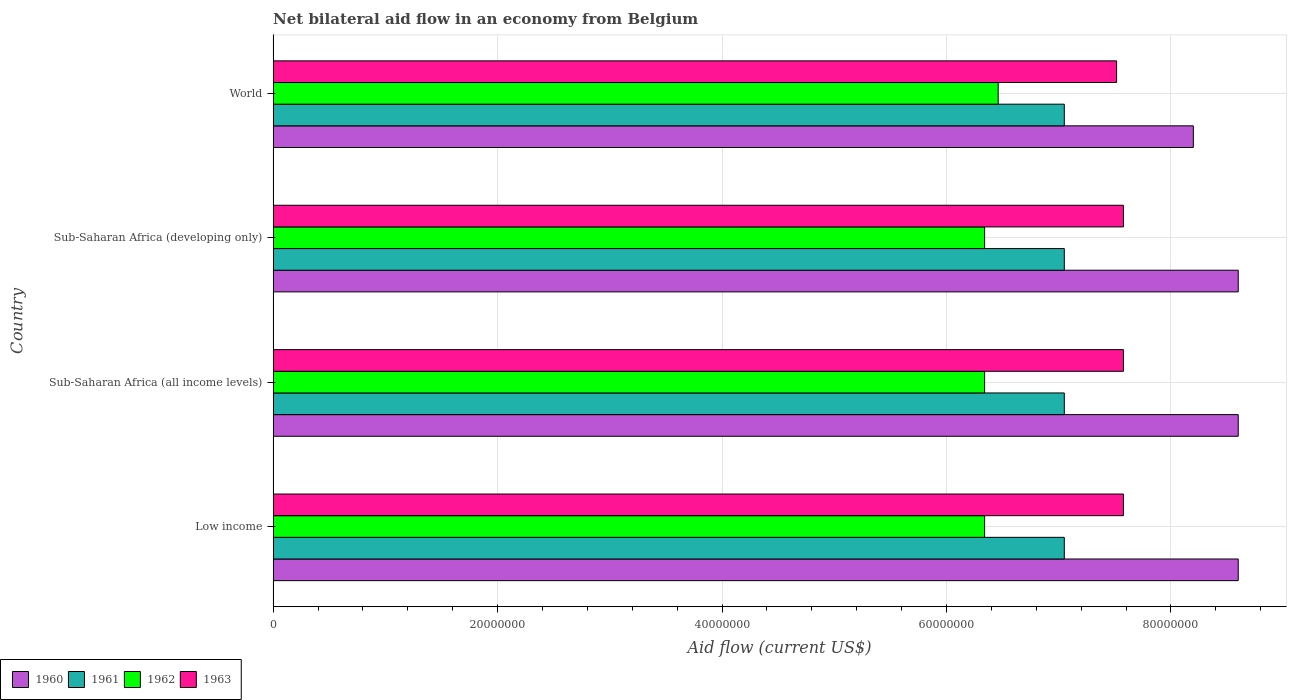How many different coloured bars are there?
Offer a terse response. 4. Are the number of bars on each tick of the Y-axis equal?
Keep it short and to the point. Yes. How many bars are there on the 4th tick from the bottom?
Offer a terse response. 4. What is the label of the 2nd group of bars from the top?
Keep it short and to the point. Sub-Saharan Africa (developing only). In how many cases, is the number of bars for a given country not equal to the number of legend labels?
Provide a succinct answer. 0. What is the net bilateral aid flow in 1960 in Low income?
Ensure brevity in your answer.  8.60e+07. Across all countries, what is the maximum net bilateral aid flow in 1962?
Your response must be concise. 6.46e+07. Across all countries, what is the minimum net bilateral aid flow in 1960?
Offer a very short reply. 8.20e+07. In which country was the net bilateral aid flow in 1961 maximum?
Provide a succinct answer. Low income. What is the total net bilateral aid flow in 1960 in the graph?
Provide a short and direct response. 3.40e+08. What is the difference between the net bilateral aid flow in 1962 in Sub-Saharan Africa (all income levels) and that in World?
Your response must be concise. -1.21e+06. What is the difference between the net bilateral aid flow in 1961 in Sub-Saharan Africa (all income levels) and the net bilateral aid flow in 1960 in World?
Offer a terse response. -1.15e+07. What is the average net bilateral aid flow in 1960 per country?
Your answer should be compact. 8.50e+07. What is the difference between the net bilateral aid flow in 1962 and net bilateral aid flow in 1960 in World?
Give a very brief answer. -1.74e+07. What is the ratio of the net bilateral aid flow in 1960 in Sub-Saharan Africa (all income levels) to that in Sub-Saharan Africa (developing only)?
Provide a succinct answer. 1. Is the sum of the net bilateral aid flow in 1961 in Low income and Sub-Saharan Africa (developing only) greater than the maximum net bilateral aid flow in 1963 across all countries?
Give a very brief answer. Yes. Is it the case that in every country, the sum of the net bilateral aid flow in 1963 and net bilateral aid flow in 1962 is greater than the sum of net bilateral aid flow in 1961 and net bilateral aid flow in 1960?
Offer a very short reply. No. What does the 2nd bar from the bottom in Low income represents?
Your answer should be compact. 1961. Are all the bars in the graph horizontal?
Make the answer very short. Yes. How many countries are there in the graph?
Ensure brevity in your answer.  4. Does the graph contain grids?
Offer a terse response. Yes. Where does the legend appear in the graph?
Your answer should be very brief. Bottom left. How many legend labels are there?
Ensure brevity in your answer.  4. How are the legend labels stacked?
Your answer should be very brief. Horizontal. What is the title of the graph?
Give a very brief answer. Net bilateral aid flow in an economy from Belgium. Does "2011" appear as one of the legend labels in the graph?
Give a very brief answer. No. What is the Aid flow (current US$) in 1960 in Low income?
Offer a terse response. 8.60e+07. What is the Aid flow (current US$) of 1961 in Low income?
Give a very brief answer. 7.05e+07. What is the Aid flow (current US$) in 1962 in Low income?
Your answer should be very brief. 6.34e+07. What is the Aid flow (current US$) of 1963 in Low income?
Make the answer very short. 7.58e+07. What is the Aid flow (current US$) in 1960 in Sub-Saharan Africa (all income levels)?
Your response must be concise. 8.60e+07. What is the Aid flow (current US$) in 1961 in Sub-Saharan Africa (all income levels)?
Offer a terse response. 7.05e+07. What is the Aid flow (current US$) in 1962 in Sub-Saharan Africa (all income levels)?
Provide a succinct answer. 6.34e+07. What is the Aid flow (current US$) of 1963 in Sub-Saharan Africa (all income levels)?
Your answer should be very brief. 7.58e+07. What is the Aid flow (current US$) of 1960 in Sub-Saharan Africa (developing only)?
Provide a succinct answer. 8.60e+07. What is the Aid flow (current US$) of 1961 in Sub-Saharan Africa (developing only)?
Ensure brevity in your answer.  7.05e+07. What is the Aid flow (current US$) of 1962 in Sub-Saharan Africa (developing only)?
Your answer should be very brief. 6.34e+07. What is the Aid flow (current US$) of 1963 in Sub-Saharan Africa (developing only)?
Your response must be concise. 7.58e+07. What is the Aid flow (current US$) of 1960 in World?
Your answer should be compact. 8.20e+07. What is the Aid flow (current US$) in 1961 in World?
Offer a very short reply. 7.05e+07. What is the Aid flow (current US$) of 1962 in World?
Your answer should be very brief. 6.46e+07. What is the Aid flow (current US$) of 1963 in World?
Your response must be concise. 7.52e+07. Across all countries, what is the maximum Aid flow (current US$) of 1960?
Ensure brevity in your answer.  8.60e+07. Across all countries, what is the maximum Aid flow (current US$) of 1961?
Provide a succinct answer. 7.05e+07. Across all countries, what is the maximum Aid flow (current US$) in 1962?
Provide a succinct answer. 6.46e+07. Across all countries, what is the maximum Aid flow (current US$) of 1963?
Your answer should be very brief. 7.58e+07. Across all countries, what is the minimum Aid flow (current US$) of 1960?
Offer a very short reply. 8.20e+07. Across all countries, what is the minimum Aid flow (current US$) in 1961?
Keep it short and to the point. 7.05e+07. Across all countries, what is the minimum Aid flow (current US$) in 1962?
Your answer should be compact. 6.34e+07. Across all countries, what is the minimum Aid flow (current US$) of 1963?
Offer a very short reply. 7.52e+07. What is the total Aid flow (current US$) in 1960 in the graph?
Give a very brief answer. 3.40e+08. What is the total Aid flow (current US$) of 1961 in the graph?
Provide a short and direct response. 2.82e+08. What is the total Aid flow (current US$) in 1962 in the graph?
Provide a short and direct response. 2.55e+08. What is the total Aid flow (current US$) of 1963 in the graph?
Keep it short and to the point. 3.02e+08. What is the difference between the Aid flow (current US$) of 1962 in Low income and that in Sub-Saharan Africa (all income levels)?
Ensure brevity in your answer.  0. What is the difference between the Aid flow (current US$) in 1963 in Low income and that in Sub-Saharan Africa (all income levels)?
Your answer should be very brief. 0. What is the difference between the Aid flow (current US$) of 1960 in Low income and that in Sub-Saharan Africa (developing only)?
Give a very brief answer. 0. What is the difference between the Aid flow (current US$) of 1962 in Low income and that in Sub-Saharan Africa (developing only)?
Your response must be concise. 0. What is the difference between the Aid flow (current US$) of 1961 in Low income and that in World?
Keep it short and to the point. 0. What is the difference between the Aid flow (current US$) in 1962 in Low income and that in World?
Your response must be concise. -1.21e+06. What is the difference between the Aid flow (current US$) of 1962 in Sub-Saharan Africa (all income levels) and that in Sub-Saharan Africa (developing only)?
Provide a succinct answer. 0. What is the difference between the Aid flow (current US$) in 1963 in Sub-Saharan Africa (all income levels) and that in Sub-Saharan Africa (developing only)?
Your answer should be very brief. 0. What is the difference between the Aid flow (current US$) in 1962 in Sub-Saharan Africa (all income levels) and that in World?
Offer a very short reply. -1.21e+06. What is the difference between the Aid flow (current US$) of 1963 in Sub-Saharan Africa (all income levels) and that in World?
Your answer should be very brief. 6.10e+05. What is the difference between the Aid flow (current US$) of 1960 in Sub-Saharan Africa (developing only) and that in World?
Ensure brevity in your answer.  4.00e+06. What is the difference between the Aid flow (current US$) in 1961 in Sub-Saharan Africa (developing only) and that in World?
Your answer should be very brief. 0. What is the difference between the Aid flow (current US$) in 1962 in Sub-Saharan Africa (developing only) and that in World?
Give a very brief answer. -1.21e+06. What is the difference between the Aid flow (current US$) in 1960 in Low income and the Aid flow (current US$) in 1961 in Sub-Saharan Africa (all income levels)?
Provide a short and direct response. 1.55e+07. What is the difference between the Aid flow (current US$) in 1960 in Low income and the Aid flow (current US$) in 1962 in Sub-Saharan Africa (all income levels)?
Your response must be concise. 2.26e+07. What is the difference between the Aid flow (current US$) in 1960 in Low income and the Aid flow (current US$) in 1963 in Sub-Saharan Africa (all income levels)?
Offer a terse response. 1.02e+07. What is the difference between the Aid flow (current US$) of 1961 in Low income and the Aid flow (current US$) of 1962 in Sub-Saharan Africa (all income levels)?
Offer a very short reply. 7.10e+06. What is the difference between the Aid flow (current US$) in 1961 in Low income and the Aid flow (current US$) in 1963 in Sub-Saharan Africa (all income levels)?
Your answer should be very brief. -5.27e+06. What is the difference between the Aid flow (current US$) of 1962 in Low income and the Aid flow (current US$) of 1963 in Sub-Saharan Africa (all income levels)?
Your response must be concise. -1.24e+07. What is the difference between the Aid flow (current US$) of 1960 in Low income and the Aid flow (current US$) of 1961 in Sub-Saharan Africa (developing only)?
Offer a terse response. 1.55e+07. What is the difference between the Aid flow (current US$) in 1960 in Low income and the Aid flow (current US$) in 1962 in Sub-Saharan Africa (developing only)?
Keep it short and to the point. 2.26e+07. What is the difference between the Aid flow (current US$) in 1960 in Low income and the Aid flow (current US$) in 1963 in Sub-Saharan Africa (developing only)?
Your answer should be very brief. 1.02e+07. What is the difference between the Aid flow (current US$) in 1961 in Low income and the Aid flow (current US$) in 1962 in Sub-Saharan Africa (developing only)?
Give a very brief answer. 7.10e+06. What is the difference between the Aid flow (current US$) of 1961 in Low income and the Aid flow (current US$) of 1963 in Sub-Saharan Africa (developing only)?
Your answer should be very brief. -5.27e+06. What is the difference between the Aid flow (current US$) in 1962 in Low income and the Aid flow (current US$) in 1963 in Sub-Saharan Africa (developing only)?
Make the answer very short. -1.24e+07. What is the difference between the Aid flow (current US$) of 1960 in Low income and the Aid flow (current US$) of 1961 in World?
Your response must be concise. 1.55e+07. What is the difference between the Aid flow (current US$) in 1960 in Low income and the Aid flow (current US$) in 1962 in World?
Offer a very short reply. 2.14e+07. What is the difference between the Aid flow (current US$) of 1960 in Low income and the Aid flow (current US$) of 1963 in World?
Offer a very short reply. 1.08e+07. What is the difference between the Aid flow (current US$) of 1961 in Low income and the Aid flow (current US$) of 1962 in World?
Your answer should be very brief. 5.89e+06. What is the difference between the Aid flow (current US$) in 1961 in Low income and the Aid flow (current US$) in 1963 in World?
Your response must be concise. -4.66e+06. What is the difference between the Aid flow (current US$) of 1962 in Low income and the Aid flow (current US$) of 1963 in World?
Provide a succinct answer. -1.18e+07. What is the difference between the Aid flow (current US$) of 1960 in Sub-Saharan Africa (all income levels) and the Aid flow (current US$) of 1961 in Sub-Saharan Africa (developing only)?
Provide a succinct answer. 1.55e+07. What is the difference between the Aid flow (current US$) of 1960 in Sub-Saharan Africa (all income levels) and the Aid flow (current US$) of 1962 in Sub-Saharan Africa (developing only)?
Your answer should be compact. 2.26e+07. What is the difference between the Aid flow (current US$) of 1960 in Sub-Saharan Africa (all income levels) and the Aid flow (current US$) of 1963 in Sub-Saharan Africa (developing only)?
Offer a very short reply. 1.02e+07. What is the difference between the Aid flow (current US$) in 1961 in Sub-Saharan Africa (all income levels) and the Aid flow (current US$) in 1962 in Sub-Saharan Africa (developing only)?
Keep it short and to the point. 7.10e+06. What is the difference between the Aid flow (current US$) in 1961 in Sub-Saharan Africa (all income levels) and the Aid flow (current US$) in 1963 in Sub-Saharan Africa (developing only)?
Provide a succinct answer. -5.27e+06. What is the difference between the Aid flow (current US$) of 1962 in Sub-Saharan Africa (all income levels) and the Aid flow (current US$) of 1963 in Sub-Saharan Africa (developing only)?
Give a very brief answer. -1.24e+07. What is the difference between the Aid flow (current US$) in 1960 in Sub-Saharan Africa (all income levels) and the Aid flow (current US$) in 1961 in World?
Your answer should be compact. 1.55e+07. What is the difference between the Aid flow (current US$) in 1960 in Sub-Saharan Africa (all income levels) and the Aid flow (current US$) in 1962 in World?
Make the answer very short. 2.14e+07. What is the difference between the Aid flow (current US$) in 1960 in Sub-Saharan Africa (all income levels) and the Aid flow (current US$) in 1963 in World?
Your answer should be very brief. 1.08e+07. What is the difference between the Aid flow (current US$) in 1961 in Sub-Saharan Africa (all income levels) and the Aid flow (current US$) in 1962 in World?
Make the answer very short. 5.89e+06. What is the difference between the Aid flow (current US$) of 1961 in Sub-Saharan Africa (all income levels) and the Aid flow (current US$) of 1963 in World?
Your answer should be very brief. -4.66e+06. What is the difference between the Aid flow (current US$) in 1962 in Sub-Saharan Africa (all income levels) and the Aid flow (current US$) in 1963 in World?
Offer a very short reply. -1.18e+07. What is the difference between the Aid flow (current US$) in 1960 in Sub-Saharan Africa (developing only) and the Aid flow (current US$) in 1961 in World?
Your answer should be very brief. 1.55e+07. What is the difference between the Aid flow (current US$) in 1960 in Sub-Saharan Africa (developing only) and the Aid flow (current US$) in 1962 in World?
Ensure brevity in your answer.  2.14e+07. What is the difference between the Aid flow (current US$) of 1960 in Sub-Saharan Africa (developing only) and the Aid flow (current US$) of 1963 in World?
Offer a very short reply. 1.08e+07. What is the difference between the Aid flow (current US$) of 1961 in Sub-Saharan Africa (developing only) and the Aid flow (current US$) of 1962 in World?
Give a very brief answer. 5.89e+06. What is the difference between the Aid flow (current US$) of 1961 in Sub-Saharan Africa (developing only) and the Aid flow (current US$) of 1963 in World?
Keep it short and to the point. -4.66e+06. What is the difference between the Aid flow (current US$) of 1962 in Sub-Saharan Africa (developing only) and the Aid flow (current US$) of 1963 in World?
Your answer should be compact. -1.18e+07. What is the average Aid flow (current US$) in 1960 per country?
Your answer should be very brief. 8.50e+07. What is the average Aid flow (current US$) in 1961 per country?
Give a very brief answer. 7.05e+07. What is the average Aid flow (current US$) of 1962 per country?
Offer a terse response. 6.37e+07. What is the average Aid flow (current US$) of 1963 per country?
Give a very brief answer. 7.56e+07. What is the difference between the Aid flow (current US$) of 1960 and Aid flow (current US$) of 1961 in Low income?
Make the answer very short. 1.55e+07. What is the difference between the Aid flow (current US$) of 1960 and Aid flow (current US$) of 1962 in Low income?
Keep it short and to the point. 2.26e+07. What is the difference between the Aid flow (current US$) in 1960 and Aid flow (current US$) in 1963 in Low income?
Your answer should be compact. 1.02e+07. What is the difference between the Aid flow (current US$) in 1961 and Aid flow (current US$) in 1962 in Low income?
Ensure brevity in your answer.  7.10e+06. What is the difference between the Aid flow (current US$) of 1961 and Aid flow (current US$) of 1963 in Low income?
Provide a short and direct response. -5.27e+06. What is the difference between the Aid flow (current US$) of 1962 and Aid flow (current US$) of 1963 in Low income?
Give a very brief answer. -1.24e+07. What is the difference between the Aid flow (current US$) of 1960 and Aid flow (current US$) of 1961 in Sub-Saharan Africa (all income levels)?
Ensure brevity in your answer.  1.55e+07. What is the difference between the Aid flow (current US$) in 1960 and Aid flow (current US$) in 1962 in Sub-Saharan Africa (all income levels)?
Give a very brief answer. 2.26e+07. What is the difference between the Aid flow (current US$) of 1960 and Aid flow (current US$) of 1963 in Sub-Saharan Africa (all income levels)?
Offer a very short reply. 1.02e+07. What is the difference between the Aid flow (current US$) in 1961 and Aid flow (current US$) in 1962 in Sub-Saharan Africa (all income levels)?
Your answer should be very brief. 7.10e+06. What is the difference between the Aid flow (current US$) in 1961 and Aid flow (current US$) in 1963 in Sub-Saharan Africa (all income levels)?
Your answer should be very brief. -5.27e+06. What is the difference between the Aid flow (current US$) of 1962 and Aid flow (current US$) of 1963 in Sub-Saharan Africa (all income levels)?
Your answer should be very brief. -1.24e+07. What is the difference between the Aid flow (current US$) of 1960 and Aid flow (current US$) of 1961 in Sub-Saharan Africa (developing only)?
Your answer should be very brief. 1.55e+07. What is the difference between the Aid flow (current US$) in 1960 and Aid flow (current US$) in 1962 in Sub-Saharan Africa (developing only)?
Ensure brevity in your answer.  2.26e+07. What is the difference between the Aid flow (current US$) of 1960 and Aid flow (current US$) of 1963 in Sub-Saharan Africa (developing only)?
Your response must be concise. 1.02e+07. What is the difference between the Aid flow (current US$) of 1961 and Aid flow (current US$) of 1962 in Sub-Saharan Africa (developing only)?
Ensure brevity in your answer.  7.10e+06. What is the difference between the Aid flow (current US$) in 1961 and Aid flow (current US$) in 1963 in Sub-Saharan Africa (developing only)?
Your answer should be compact. -5.27e+06. What is the difference between the Aid flow (current US$) of 1962 and Aid flow (current US$) of 1963 in Sub-Saharan Africa (developing only)?
Your answer should be compact. -1.24e+07. What is the difference between the Aid flow (current US$) in 1960 and Aid flow (current US$) in 1961 in World?
Give a very brief answer. 1.15e+07. What is the difference between the Aid flow (current US$) in 1960 and Aid flow (current US$) in 1962 in World?
Ensure brevity in your answer.  1.74e+07. What is the difference between the Aid flow (current US$) in 1960 and Aid flow (current US$) in 1963 in World?
Ensure brevity in your answer.  6.84e+06. What is the difference between the Aid flow (current US$) in 1961 and Aid flow (current US$) in 1962 in World?
Offer a terse response. 5.89e+06. What is the difference between the Aid flow (current US$) in 1961 and Aid flow (current US$) in 1963 in World?
Your answer should be compact. -4.66e+06. What is the difference between the Aid flow (current US$) in 1962 and Aid flow (current US$) in 1963 in World?
Provide a succinct answer. -1.06e+07. What is the ratio of the Aid flow (current US$) in 1960 in Low income to that in Sub-Saharan Africa (all income levels)?
Provide a short and direct response. 1. What is the ratio of the Aid flow (current US$) of 1962 in Low income to that in Sub-Saharan Africa (all income levels)?
Your answer should be compact. 1. What is the ratio of the Aid flow (current US$) in 1963 in Low income to that in Sub-Saharan Africa (all income levels)?
Offer a very short reply. 1. What is the ratio of the Aid flow (current US$) of 1961 in Low income to that in Sub-Saharan Africa (developing only)?
Make the answer very short. 1. What is the ratio of the Aid flow (current US$) of 1963 in Low income to that in Sub-Saharan Africa (developing only)?
Make the answer very short. 1. What is the ratio of the Aid flow (current US$) in 1960 in Low income to that in World?
Provide a succinct answer. 1.05. What is the ratio of the Aid flow (current US$) in 1962 in Low income to that in World?
Your answer should be compact. 0.98. What is the ratio of the Aid flow (current US$) of 1961 in Sub-Saharan Africa (all income levels) to that in Sub-Saharan Africa (developing only)?
Give a very brief answer. 1. What is the ratio of the Aid flow (current US$) in 1960 in Sub-Saharan Africa (all income levels) to that in World?
Offer a terse response. 1.05. What is the ratio of the Aid flow (current US$) of 1962 in Sub-Saharan Africa (all income levels) to that in World?
Your answer should be compact. 0.98. What is the ratio of the Aid flow (current US$) in 1960 in Sub-Saharan Africa (developing only) to that in World?
Give a very brief answer. 1.05. What is the ratio of the Aid flow (current US$) in 1962 in Sub-Saharan Africa (developing only) to that in World?
Make the answer very short. 0.98. What is the difference between the highest and the second highest Aid flow (current US$) of 1960?
Offer a terse response. 0. What is the difference between the highest and the second highest Aid flow (current US$) in 1962?
Your answer should be compact. 1.21e+06. What is the difference between the highest and the second highest Aid flow (current US$) in 1963?
Offer a very short reply. 0. What is the difference between the highest and the lowest Aid flow (current US$) in 1961?
Your answer should be compact. 0. What is the difference between the highest and the lowest Aid flow (current US$) of 1962?
Give a very brief answer. 1.21e+06. What is the difference between the highest and the lowest Aid flow (current US$) of 1963?
Provide a short and direct response. 6.10e+05. 